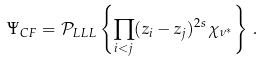<formula> <loc_0><loc_0><loc_500><loc_500>\Psi _ { C F } = { \mathcal { P } } _ { L L L } \left \{ \prod _ { i < j } ( z _ { i } - z _ { j } ) ^ { 2 s } \, \chi _ { \nu ^ { * } } \right \} \, .</formula> 